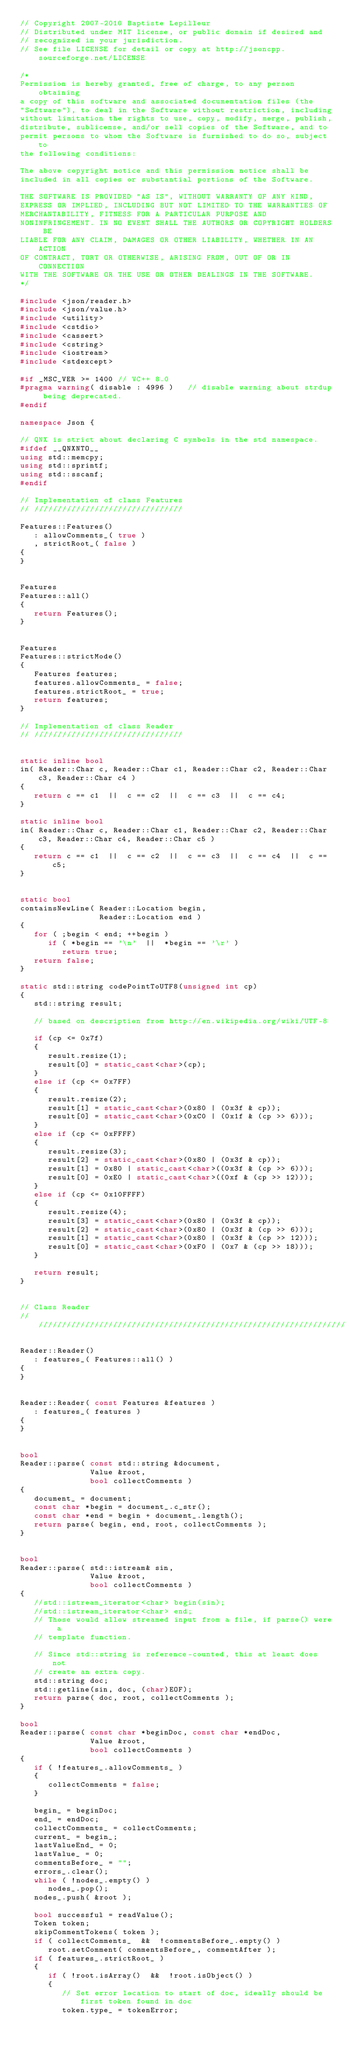Convert code to text. <code><loc_0><loc_0><loc_500><loc_500><_C++_>// Copyright 2007-2010 Baptiste Lepilleur
// Distributed under MIT license, or public domain if desired and
// recognized in your jurisdiction.
// See file LICENSE for detail or copy at http://jsoncpp.sourceforge.net/LICENSE

/*
Permission is hereby granted, free of charge, to any person obtaining
a copy of this software and associated documentation files (the
"Software"), to deal in the Software without restriction, including
without limitation the rights to use, copy, modify, merge, publish,
distribute, sublicense, and/or sell copies of the Software, and to
permit persons to whom the Software is furnished to do so, subject to
the following conditions:

The above copyright notice and this permission notice shall be
included in all copies or substantial portions of the Software.

THE SOFTWARE IS PROVIDED "AS IS", WITHOUT WARRANTY OF ANY KIND,
EXPRESS OR IMPLIED, INCLUDING BUT NOT LIMITED TO THE WARRANTIES OF
MERCHANTABILITY, FITNESS FOR A PARTICULAR PURPOSE AND
NONINFRINGEMENT. IN NO EVENT SHALL THE AUTHORS OR COPYRIGHT HOLDERS BE
LIABLE FOR ANY CLAIM, DAMAGES OR OTHER LIABILITY, WHETHER IN AN ACTION
OF CONTRACT, TORT OR OTHERWISE, ARISING FROM, OUT OF OR IN CONNECTION
WITH THE SOFTWARE OR THE USE OR OTHER DEALINGS IN THE SOFTWARE.
*/

#include <json/reader.h>
#include <json/value.h>
#include <utility>
#include <cstdio>
#include <cassert>
#include <cstring>
#include <iostream>
#include <stdexcept>

#if _MSC_VER >= 1400 // VC++ 8.0
#pragma warning( disable : 4996 )   // disable warning about strdup being deprecated.
#endif

namespace Json {

// QNX is strict about declaring C symbols in the std namespace.
#ifdef __QNXNTO__
using std::memcpy;
using std::sprintf;
using std::sscanf;
#endif

// Implementation of class Features
// ////////////////////////////////

Features::Features()
   : allowComments_( true )
   , strictRoot_( false )
{
}


Features 
Features::all()
{
   return Features();
}


Features 
Features::strictMode()
{
   Features features;
   features.allowComments_ = false;
   features.strictRoot_ = true;
   return features;
}

// Implementation of class Reader
// ////////////////////////////////


static inline bool 
in( Reader::Char c, Reader::Char c1, Reader::Char c2, Reader::Char c3, Reader::Char c4 )
{
   return c == c1  ||  c == c2  ||  c == c3  ||  c == c4;
}

static inline bool 
in( Reader::Char c, Reader::Char c1, Reader::Char c2, Reader::Char c3, Reader::Char c4, Reader::Char c5 )
{
   return c == c1  ||  c == c2  ||  c == c3  ||  c == c4  ||  c == c5;
}


static bool 
containsNewLine( Reader::Location begin, 
                 Reader::Location end )
{
   for ( ;begin < end; ++begin )
      if ( *begin == '\n'  ||  *begin == '\r' )
         return true;
   return false;
}

static std::string codePointToUTF8(unsigned int cp)
{
   std::string result;
   
   // based on description from http://en.wikipedia.org/wiki/UTF-8

   if (cp <= 0x7f) 
   {
      result.resize(1);
      result[0] = static_cast<char>(cp);
   } 
   else if (cp <= 0x7FF) 
   {
      result.resize(2);
      result[1] = static_cast<char>(0x80 | (0x3f & cp));
      result[0] = static_cast<char>(0xC0 | (0x1f & (cp >> 6)));
   } 
   else if (cp <= 0xFFFF) 
   {
      result.resize(3);
      result[2] = static_cast<char>(0x80 | (0x3f & cp));
      result[1] = 0x80 | static_cast<char>((0x3f & (cp >> 6)));
      result[0] = 0xE0 | static_cast<char>((0xf & (cp >> 12)));
   }
   else if (cp <= 0x10FFFF) 
   {
      result.resize(4);
      result[3] = static_cast<char>(0x80 | (0x3f & cp));
      result[2] = static_cast<char>(0x80 | (0x3f & (cp >> 6)));
      result[1] = static_cast<char>(0x80 | (0x3f & (cp >> 12)));
      result[0] = static_cast<char>(0xF0 | (0x7 & (cp >> 18)));
   }

   return result;
}


// Class Reader
// //////////////////////////////////////////////////////////////////

Reader::Reader()
   : features_( Features::all() )
{
}


Reader::Reader( const Features &features )
   : features_( features )
{
}


bool
Reader::parse( const std::string &document, 
               Value &root,
               bool collectComments )
{
   document_ = document;
   const char *begin = document_.c_str();
   const char *end = begin + document_.length();
   return parse( begin, end, root, collectComments );
}


bool
Reader::parse( std::istream& sin,
               Value &root,
               bool collectComments )
{
   //std::istream_iterator<char> begin(sin);
   //std::istream_iterator<char> end;
   // Those would allow streamed input from a file, if parse() were a
   // template function.

   // Since std::string is reference-counted, this at least does not
   // create an extra copy.
   std::string doc;
   std::getline(sin, doc, (char)EOF);
   return parse( doc, root, collectComments );
}

bool 
Reader::parse( const char *beginDoc, const char *endDoc, 
               Value &root,
               bool collectComments )
{
   if ( !features_.allowComments_ )
   {
      collectComments = false;
   }

   begin_ = beginDoc;
   end_ = endDoc;
   collectComments_ = collectComments;
   current_ = begin_;
   lastValueEnd_ = 0;
   lastValue_ = 0;
   commentsBefore_ = "";
   errors_.clear();
   while ( !nodes_.empty() )
      nodes_.pop();
   nodes_.push( &root );
   
   bool successful = readValue();
   Token token;
   skipCommentTokens( token );
   if ( collectComments_  &&  !commentsBefore_.empty() )
      root.setComment( commentsBefore_, commentAfter );
   if ( features_.strictRoot_ )
   {
      if ( !root.isArray()  &&  !root.isObject() )
      {
         // Set error location to start of doc, ideally should be first token found in doc
         token.type_ = tokenError;</code> 